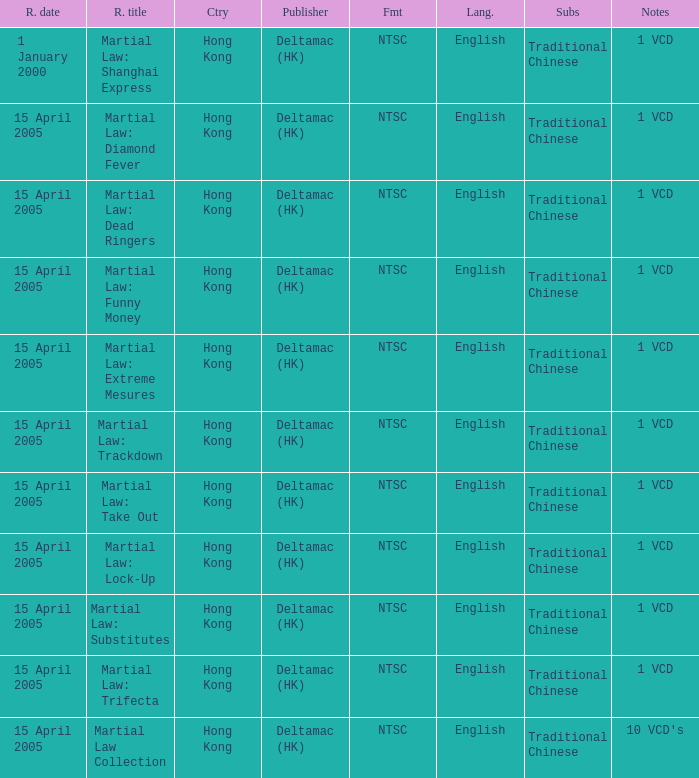What is the release date of Martial Law: Take Out? 15 April 2005. 